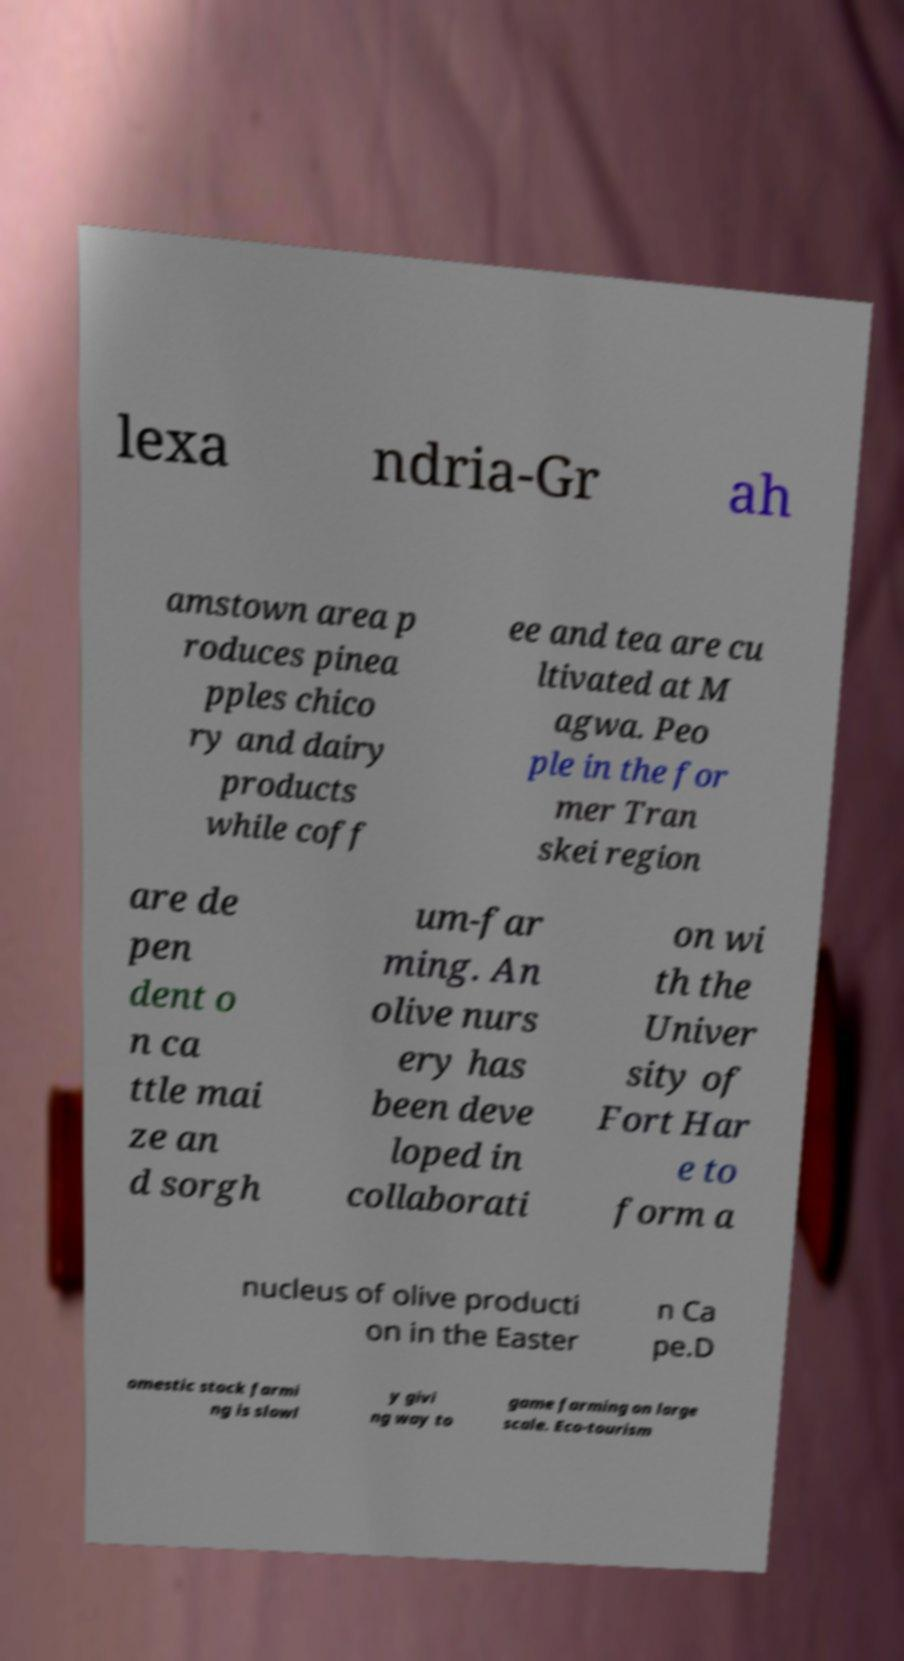What messages or text are displayed in this image? I need them in a readable, typed format. lexa ndria-Gr ah amstown area p roduces pinea pples chico ry and dairy products while coff ee and tea are cu ltivated at M agwa. Peo ple in the for mer Tran skei region are de pen dent o n ca ttle mai ze an d sorgh um-far ming. An olive nurs ery has been deve loped in collaborati on wi th the Univer sity of Fort Har e to form a nucleus of olive producti on in the Easter n Ca pe.D omestic stock farmi ng is slowl y givi ng way to game farming on large scale. Eco-tourism 